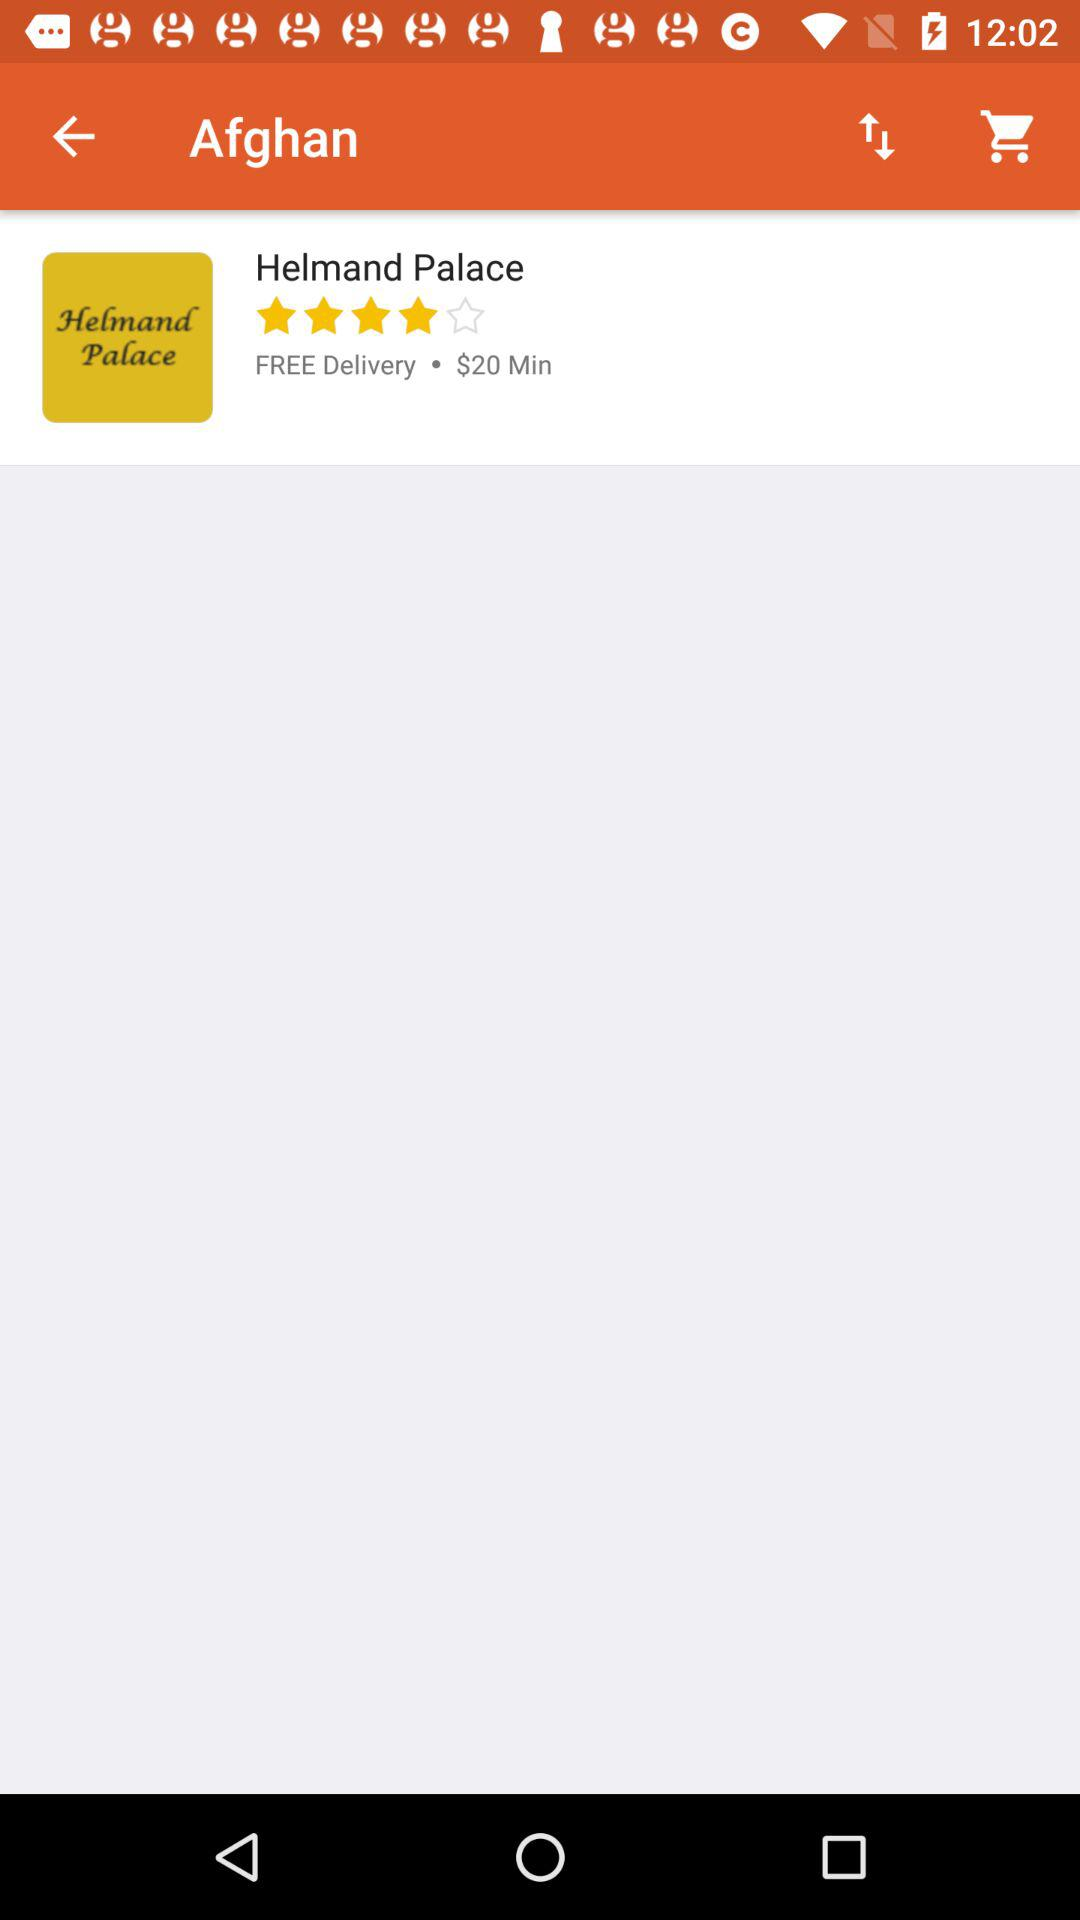Is delivery free or paid? The delivery is free. 